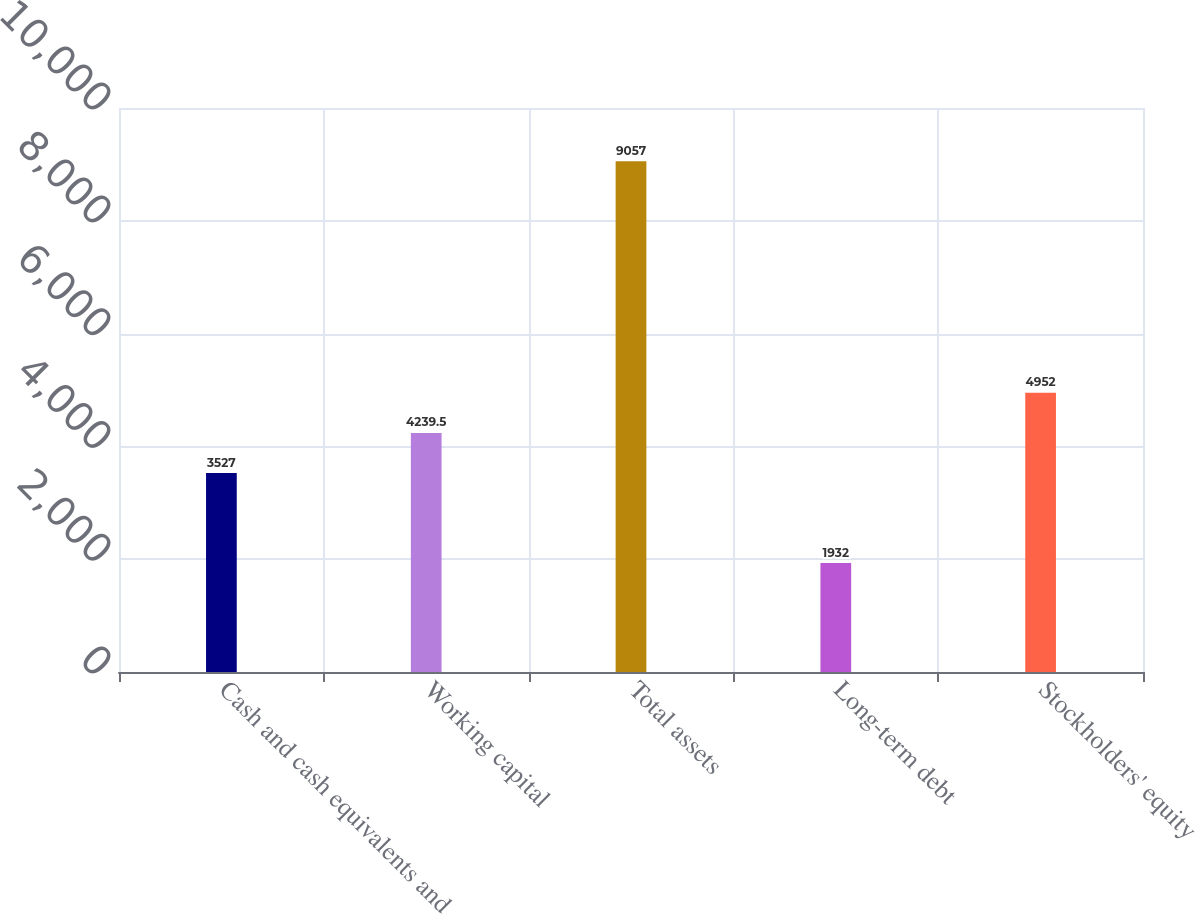<chart> <loc_0><loc_0><loc_500><loc_500><bar_chart><fcel>Cash and cash equivalents and<fcel>Working capital<fcel>Total assets<fcel>Long-term debt<fcel>Stockholders' equity<nl><fcel>3527<fcel>4239.5<fcel>9057<fcel>1932<fcel>4952<nl></chart> 